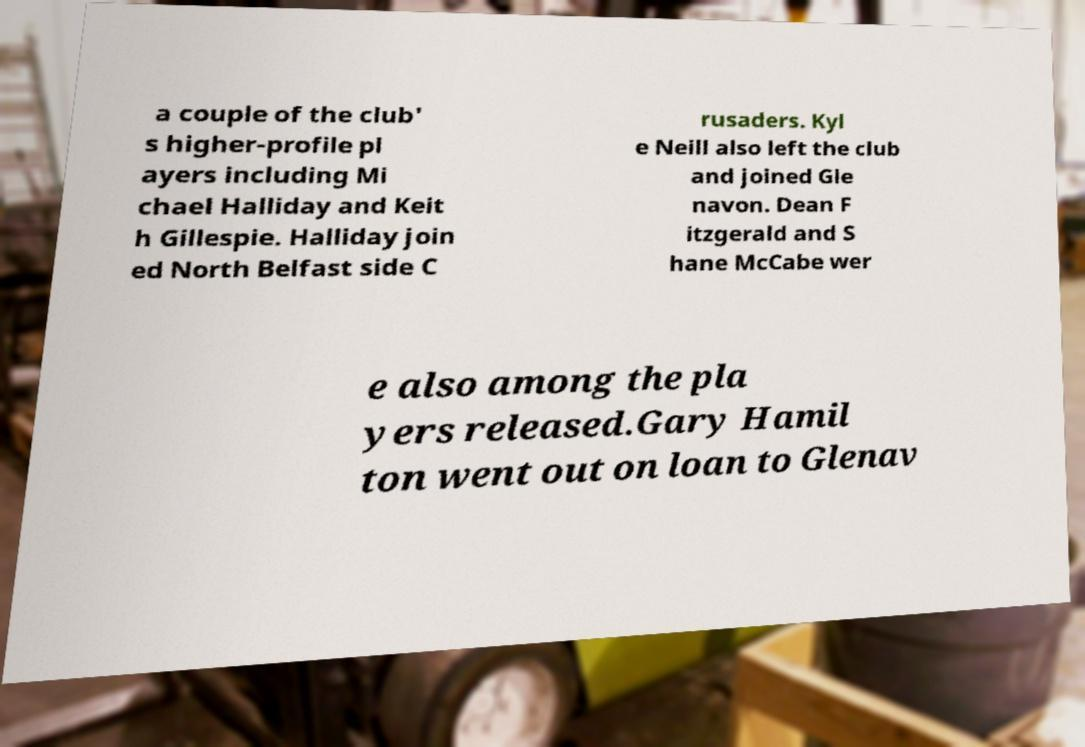Could you assist in decoding the text presented in this image and type it out clearly? a couple of the club' s higher-profile pl ayers including Mi chael Halliday and Keit h Gillespie. Halliday join ed North Belfast side C rusaders. Kyl e Neill also left the club and joined Gle navon. Dean F itzgerald and S hane McCabe wer e also among the pla yers released.Gary Hamil ton went out on loan to Glenav 